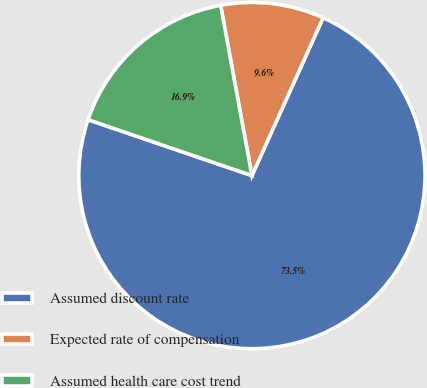Convert chart to OTSL. <chart><loc_0><loc_0><loc_500><loc_500><pie_chart><fcel>Assumed discount rate<fcel>Expected rate of compensation<fcel>Assumed health care cost trend<nl><fcel>73.49%<fcel>9.64%<fcel>16.87%<nl></chart> 